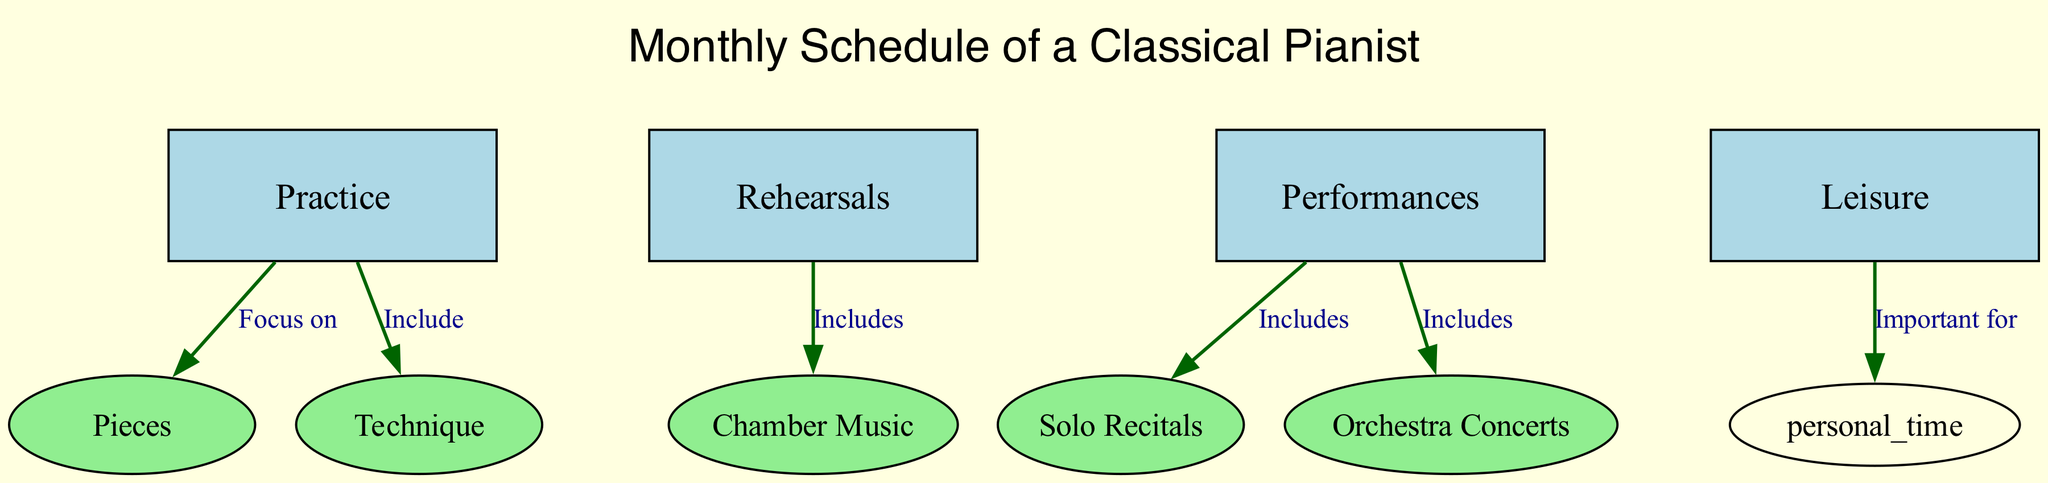What are the main activities in the monthly schedule? The nodes labeled "Practice," "Rehearsals," "Performances," and "Leisure" represent the primary activities scheduled for the classical pianist each month. These are clearly delineated in rectangular nodes, indicating their significance in the overall plan.
Answer: Practice, Rehearsals, Performances, Leisure How many edges are there in the diagram? By counting the connections (edges) represented in the diagram, there are a total of six edges connecting the various nodes, demonstrating the relationships between the different activities.
Answer: 6 What specific types of performances are included? The edge from "Performances" to "Solo Recitals" and "Orchestra Concerts" shows that these two types are part of the scheduled activities for performances. Both activities are essential components of a classical pianist's schedule.
Answer: Solo Recitals, Orchestra Concerts Which practice techniques are included in the schedule? The connection from "Practice" to "Technique" indicates that techniques such as scales, arpeggios, and exercises are part of the practice sessions. This shows the focus on technical skill development within the pianist's routine.
Answer: Technique What is important for leisure time? In the diagram, the edge from "Leisure" to "personal_time" specifies that leisure time is essential for personal activities, indicating its role in maintaining balance and well-being for the pianist amidst their busy schedule.
Answer: Important for personal time Which type of music does the rehearsal focus on? The link between "Rehearsals" and "Chamber Music" clarifies that the rehearsals include ensemble practice for Mozart's String Quartets, highlighting a focus on collaborative performance of classical works.
Answer: Mozart's String Quartets How does daily practice relate to repertoire? The flow from "Practice" to "Pieces" indicates that daily practice sessions are centered on the development of specific pieces, particularly those by Mozart and Beethoven, thus illustrating the integration of repertoire in practice routines.
Answer: Focus on Pieces What type of music is emphasized in solo recitals? The relationship from "Performances" to "Solo Recitals" states that these performances feature Beethoven Sonatas, showcasing a particular emphasis on Beethoven's work during solo opportunities.
Answer: Beethoven Sonatas 